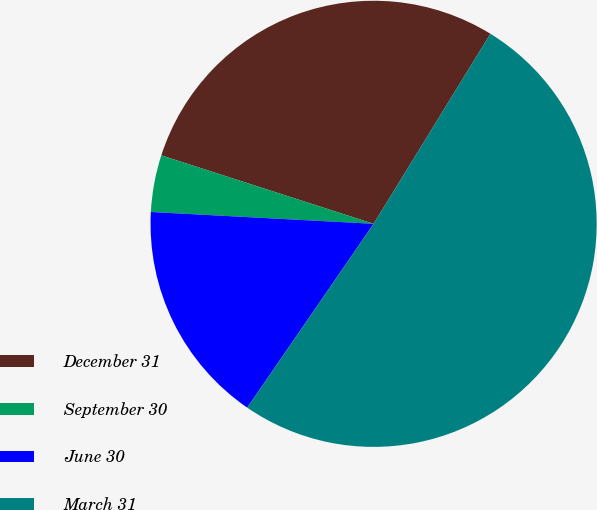Convert chart to OTSL. <chart><loc_0><loc_0><loc_500><loc_500><pie_chart><fcel>December 31<fcel>September 30<fcel>June 30<fcel>March 31<nl><fcel>28.81%<fcel>4.12%<fcel>16.26%<fcel>50.82%<nl></chart> 